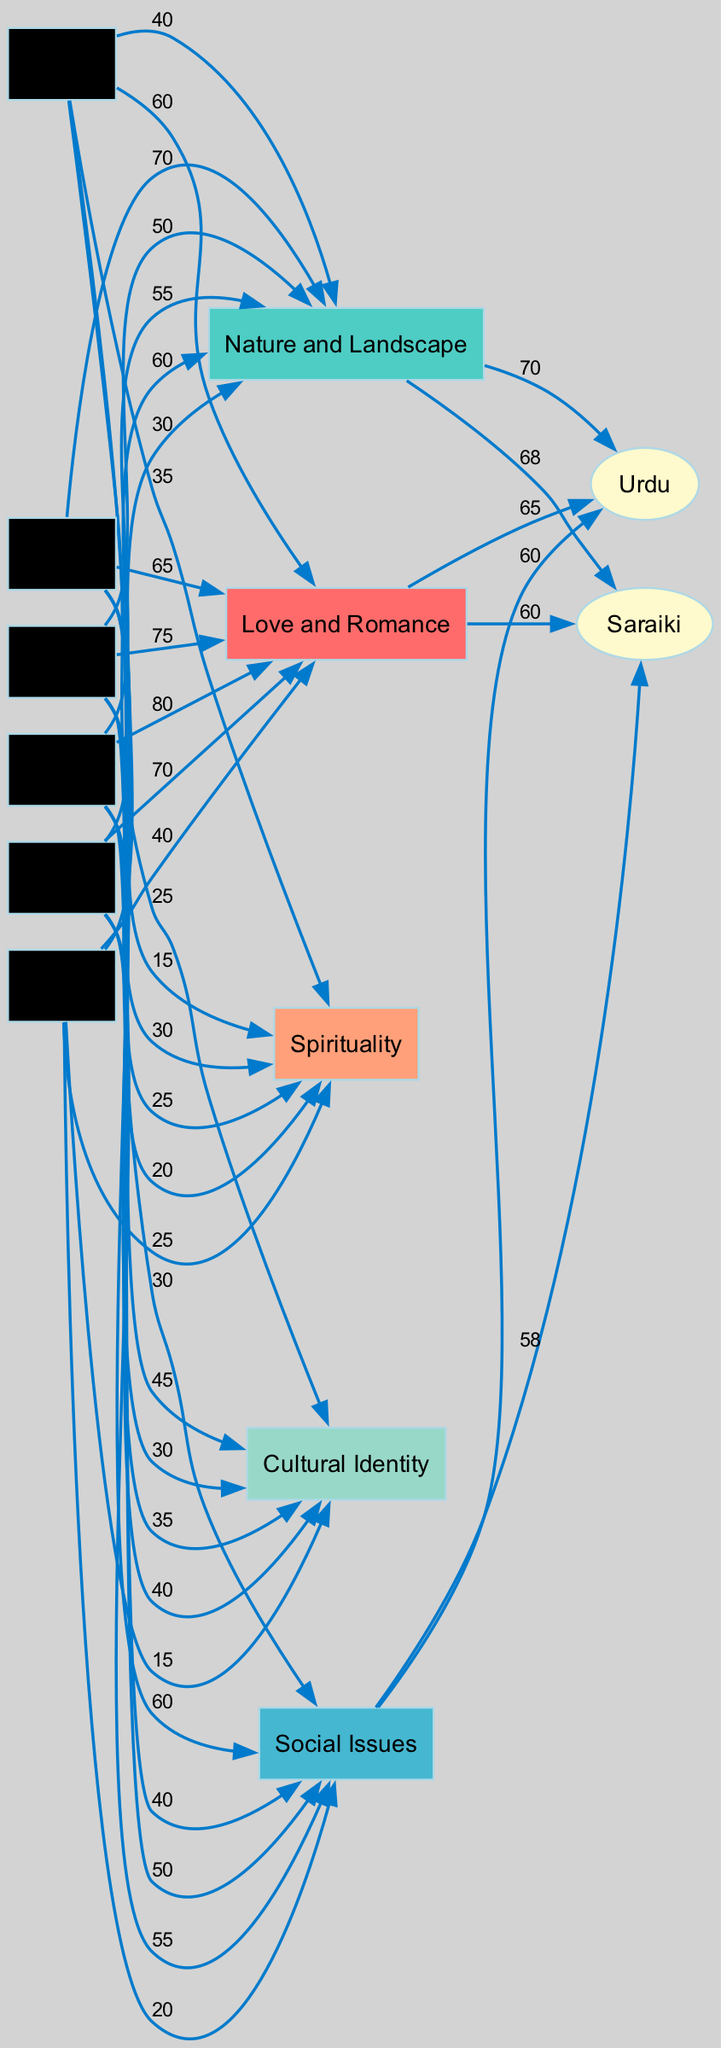What is the highest popularity score for "Love and Romance" in Urdu poetry? The diagram indicates that the highest popularity score for "Love and Romance" in Urdu poetry occurred in the 1990s, with a score of 80.
Answer: 80 Which decade saw the lowest score for "Social Issues" in Saraiki poetry? By observing the edges related to "Social Issues" for Saraiki poetry, we see that the 1960s had the lowest score of 18.
Answer: 1960s What theme had the highest growth in popularity from the 1960s to the 2010s in Urdu poetry? Analyzing the scores for each theme over the decades, "Social Issues" increased from 20 in the 1960s to 60 in the 2010s, which reflects a growth of 40. This is more than any other theme.
Answer: Social Issues Which theme is the most consistent in Saraiki poetry over the decades? Examining the popularity scores for Saraiki poetry, "Love and Romance" has the least fluctuation, maintaining scores close to each other (ranging from 35 to 75).
Answer: Love and Romance What is the popularity score of "Cultural Identity" in the 2010s? The relevant node for "Cultural Identity" indicates a score of 45 in the 2010s.
Answer: 45 Which language's poetry had a higher popularity in the "Nature and Landscape" theme in the 1980s? The procedure involves comparing the popularity scores for "Nature and Landscape" in the 1980s: Urdu scored 50, while Saraiki scored 48, indicating that Urdu poetry had a higher popularity.
Answer: Urdu What is the relationship between the "Spirituality" theme and the 2000s in Urdu poetry? By observing the edge connecting "Spirituality" to the 2000s, the popularity score is shown to be 20, indicating a low engagement with this theme in that decade.
Answer: 20 Which theme shows an increasing trend across the 2010s in both Urdu and Saraiki poetry? By analyzing the decade nodes, "Cultural Identity" shows a continuous increase for both languages, with Urdu reaching 45 and Saraiki also increasing steadily to 45.
Answer: Cultural Identity 